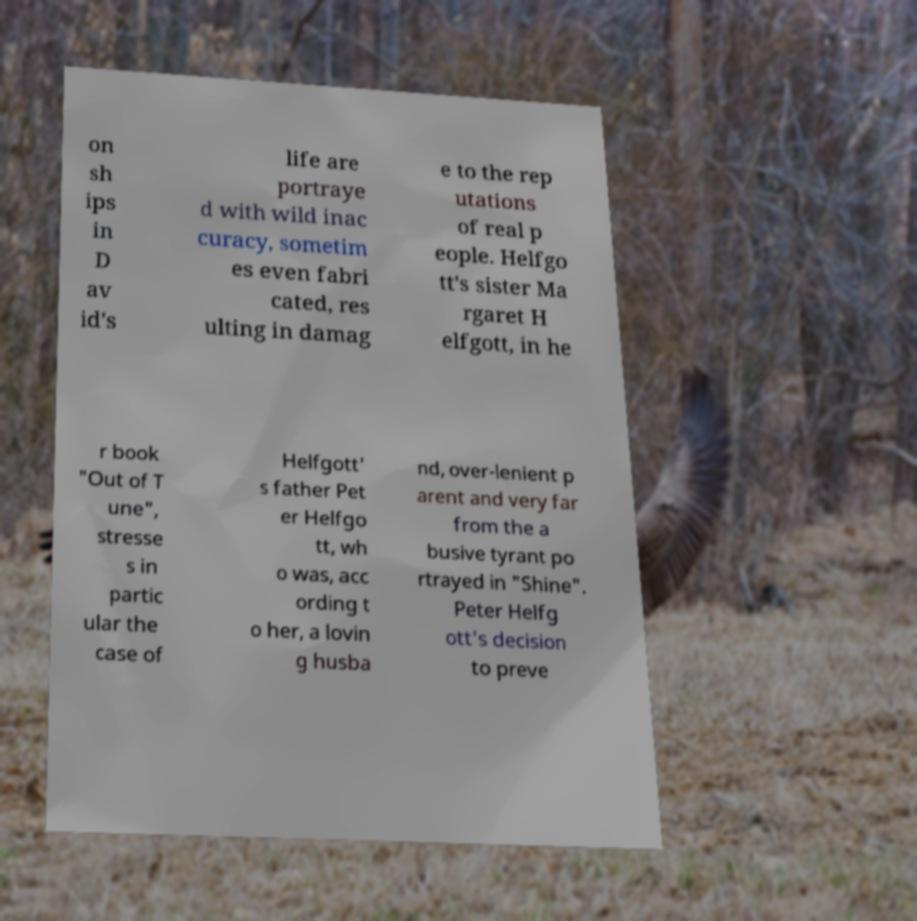Can you read and provide the text displayed in the image?This photo seems to have some interesting text. Can you extract and type it out for me? on sh ips in D av id's life are portraye d with wild inac curacy, sometim es even fabri cated, res ulting in damag e to the rep utations of real p eople. Helfgo tt's sister Ma rgaret H elfgott, in he r book "Out of T une", stresse s in partic ular the case of Helfgott' s father Pet er Helfgo tt, wh o was, acc ording t o her, a lovin g husba nd, over-lenient p arent and very far from the a busive tyrant po rtrayed in "Shine". Peter Helfg ott's decision to preve 